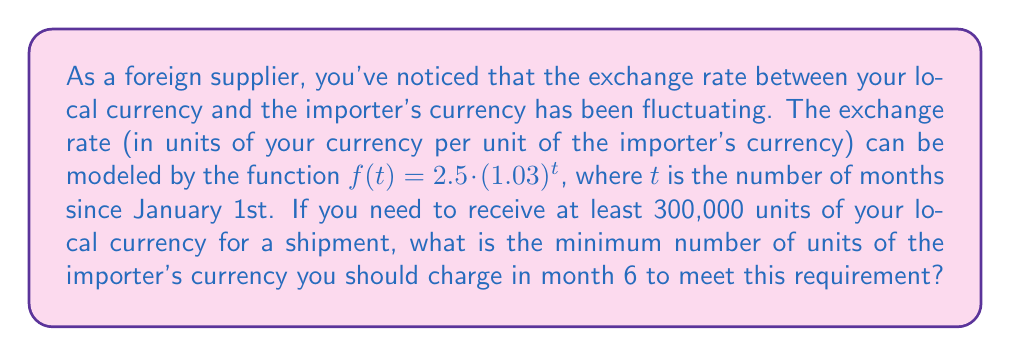Could you help me with this problem? Let's approach this step-by-step:

1) The exchange rate function is given by $f(t) = 2.5 \cdot (1.03)^t$

2) We need to find the exchange rate for month 6:
   $f(6) = 2.5 \cdot (1.03)^6 = 2.5 \cdot 1.1940... \approx 2.985$

3) This means that 1 unit of the importer's currency is worth approximately 2.985 units of your local currency in month 6.

4) Let $x$ be the number of units of the importer's currency we need to charge.

5) To meet the requirement, we need:
   $2.985x \geq 300,000$

6) Solving for $x$:
   $x \geq 300,000 / 2.985$
   $x \geq 100,502.51...$

7) Since we can't charge a fractional amount, we need to round up to the nearest whole number.
Answer: 100,503 units of the importer's currency 